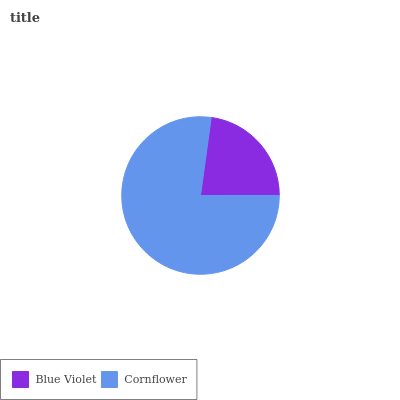Is Blue Violet the minimum?
Answer yes or no. Yes. Is Cornflower the maximum?
Answer yes or no. Yes. Is Cornflower the minimum?
Answer yes or no. No. Is Cornflower greater than Blue Violet?
Answer yes or no. Yes. Is Blue Violet less than Cornflower?
Answer yes or no. Yes. Is Blue Violet greater than Cornflower?
Answer yes or no. No. Is Cornflower less than Blue Violet?
Answer yes or no. No. Is Cornflower the high median?
Answer yes or no. Yes. Is Blue Violet the low median?
Answer yes or no. Yes. Is Blue Violet the high median?
Answer yes or no. No. Is Cornflower the low median?
Answer yes or no. No. 